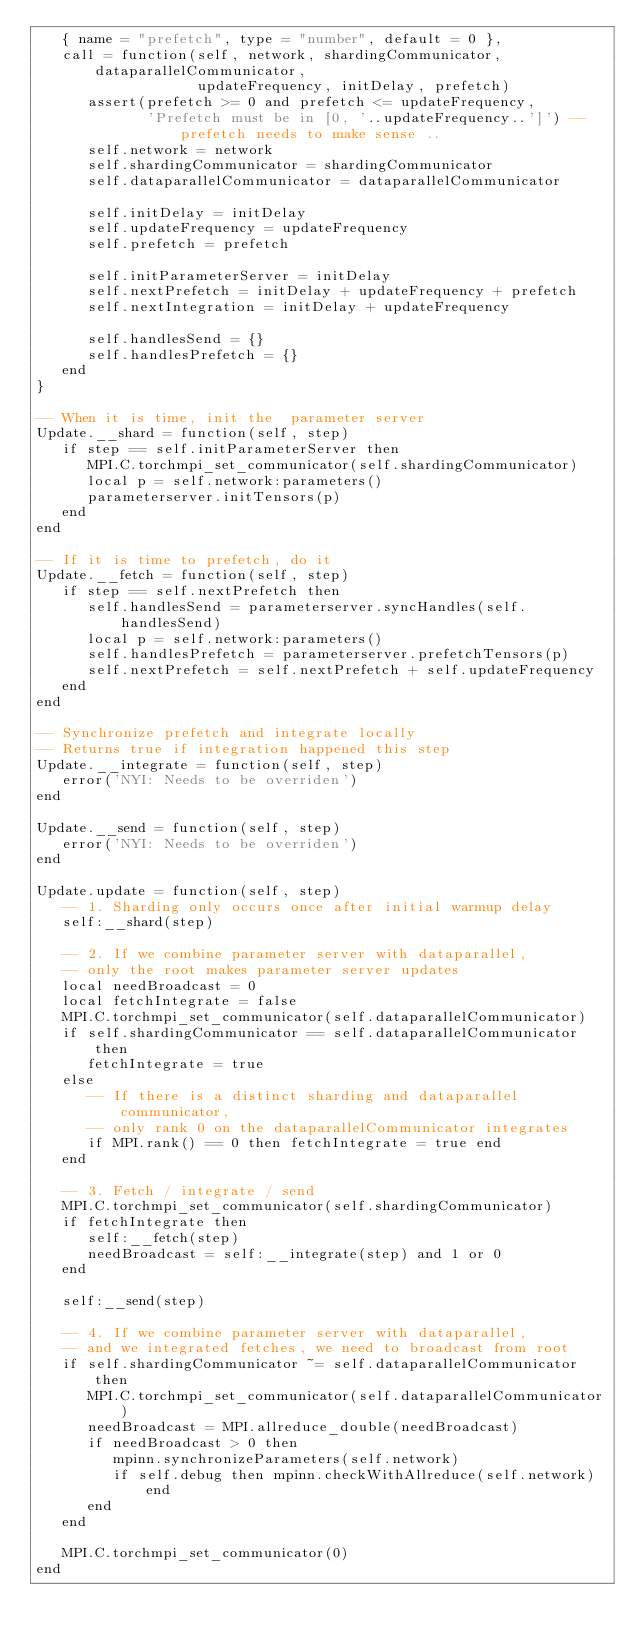Convert code to text. <code><loc_0><loc_0><loc_500><loc_500><_Lua_>   { name = "prefetch", type = "number", default = 0 },
   call = function(self, network, shardingCommunicator, dataparallelCommunicator,
                   updateFrequency, initDelay, prefetch)
      assert(prefetch >= 0 and prefetch <= updateFrequency,
             'Prefetch must be in [0, '..updateFrequency..']') -- prefetch needs to make sense ..
      self.network = network
      self.shardingCommunicator = shardingCommunicator
      self.dataparallelCommunicator = dataparallelCommunicator

      self.initDelay = initDelay
      self.updateFrequency = updateFrequency
      self.prefetch = prefetch

      self.initParameterServer = initDelay
      self.nextPrefetch = initDelay + updateFrequency + prefetch
      self.nextIntegration = initDelay + updateFrequency

      self.handlesSend = {}
      self.handlesPrefetch = {}
   end
}

-- When it is time, init the  parameter server
Update.__shard = function(self, step)
   if step == self.initParameterServer then
      MPI.C.torchmpi_set_communicator(self.shardingCommunicator)
      local p = self.network:parameters()
      parameterserver.initTensors(p)
   end
end

-- If it is time to prefetch, do it
Update.__fetch = function(self, step)
   if step == self.nextPrefetch then
      self.handlesSend = parameterserver.syncHandles(self.handlesSend)
      local p = self.network:parameters()
      self.handlesPrefetch = parameterserver.prefetchTensors(p)
      self.nextPrefetch = self.nextPrefetch + self.updateFrequency
   end
end

-- Synchronize prefetch and integrate locally
-- Returns true if integration happened this step
Update.__integrate = function(self, step)
   error('NYI: Needs to be overriden')
end

Update.__send = function(self, step)
   error('NYI: Needs to be overriden')
end

Update.update = function(self, step)
   -- 1. Sharding only occurs once after initial warmup delay
   self:__shard(step)

   -- 2. If we combine parameter server with dataparallel,
   -- only the root makes parameter server updates
   local needBroadcast = 0
   local fetchIntegrate = false
   MPI.C.torchmpi_set_communicator(self.dataparallelCommunicator)
   if self.shardingCommunicator == self.dataparallelCommunicator then
      fetchIntegrate = true
   else
      -- If there is a distinct sharding and dataparallel communicator,
      -- only rank 0 on the dataparallelCommunicator integrates
      if MPI.rank() == 0 then fetchIntegrate = true end
   end

   -- 3. Fetch / integrate / send
   MPI.C.torchmpi_set_communicator(self.shardingCommunicator)
   if fetchIntegrate then
      self:__fetch(step)
      needBroadcast = self:__integrate(step) and 1 or 0
   end

   self:__send(step)

   -- 4. If we combine parameter server with dataparallel,
   -- and we integrated fetches, we need to broadcast from root
   if self.shardingCommunicator ~= self.dataparallelCommunicator then
      MPI.C.torchmpi_set_communicator(self.dataparallelCommunicator)
      needBroadcast = MPI.allreduce_double(needBroadcast)
      if needBroadcast > 0 then
         mpinn.synchronizeParameters(self.network)
         if self.debug then mpinn.checkWithAllreduce(self.network) end
      end
   end

   MPI.C.torchmpi_set_communicator(0)
end
</code> 